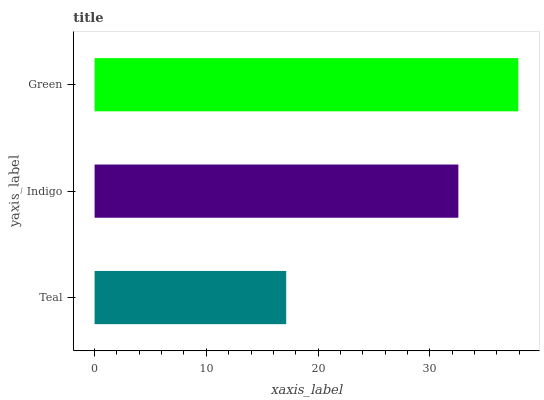Is Teal the minimum?
Answer yes or no. Yes. Is Green the maximum?
Answer yes or no. Yes. Is Indigo the minimum?
Answer yes or no. No. Is Indigo the maximum?
Answer yes or no. No. Is Indigo greater than Teal?
Answer yes or no. Yes. Is Teal less than Indigo?
Answer yes or no. Yes. Is Teal greater than Indigo?
Answer yes or no. No. Is Indigo less than Teal?
Answer yes or no. No. Is Indigo the high median?
Answer yes or no. Yes. Is Indigo the low median?
Answer yes or no. Yes. Is Teal the high median?
Answer yes or no. No. Is Teal the low median?
Answer yes or no. No. 